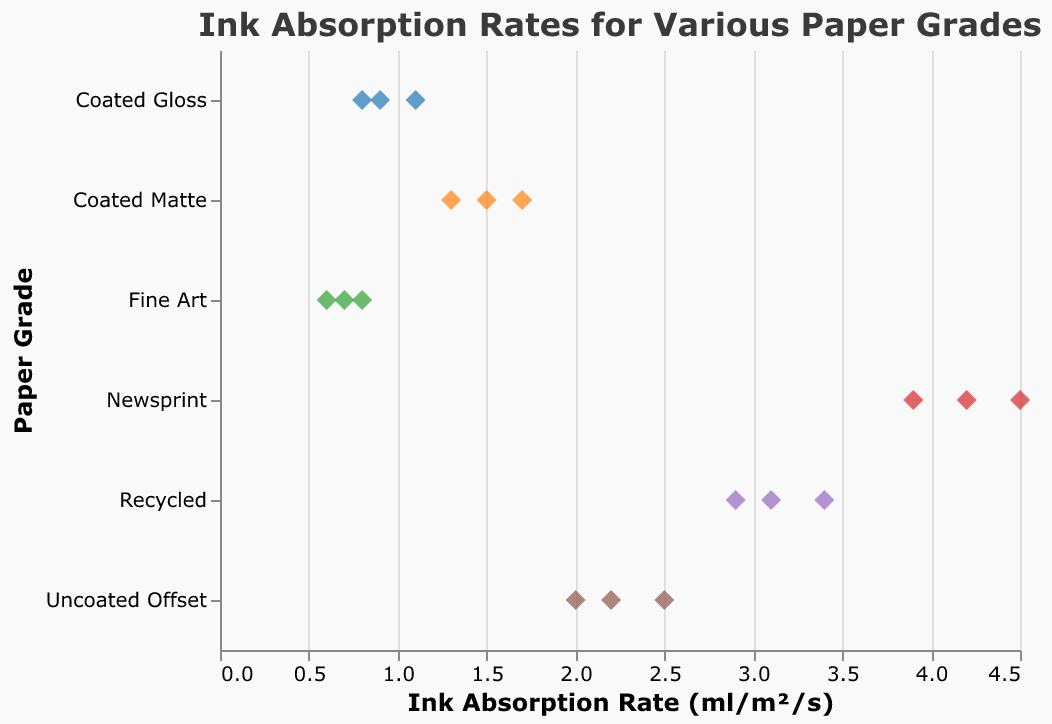What is the title of the figure? The title of the figure is displayed at the top of the plot. It summarizes the content of the plot.
Answer: Ink Absorption Rates for Various Paper Grades What are the paper grades shown on the y-axis? The y-axis displays different categories, in this case, various paper grades used in commercial printing.
Answer: Coated Gloss, Coated Matte, Uncoated Offset, Recycled, Newsprint, Fine Art Which paper grade has the highest ink absorption rate? To find the highest ink absorption rate, look for the maximum value in the horizontal direction for each paper grade. Newsprint has the highest value at 4.5 ml/m²/s.
Answer: Newsprint What is the range of ink absorption rates for Coated Matte paper? To find the range, identify the minimum and maximum values for Coated Matte paper on the x-axis. The values range from 1.3 to 1.7 ml/m²/s.
Answer: 1.3 to 1.7 ml/m²/s How does the ink absorption rate for Fine Art paper compare to Recycled paper? Compare the ink absorption rates by observing the positional range of dots on the x-axis for both Fine Art and Recycled paper grades. Fine Art paper (0.6 to 0.8 ml/m²/s) has a lower ink absorption rate range compared to Recycled paper (2.9 to 3.4 ml/m²/s).
Answer: Fine Art paper has a lower ink absorption rate Calculate the average ink absorption rate for Uncoated Offset paper. To calculate the average ink absorption rate, sum the values for Uncoated Offset paper (2.2 + 2.5 + 2.0 = 6.7) and divide by the number of data points (3).
Answer: 2.23 ml/m²/s Which paper grade has the lowest ink absorption rate? To find the lowest ink absorption rate, look for the minimum value in the horizontal direction across all paper grades. Fine Art has the lowest value at 0.6 ml/m²/s.
Answer: Fine Art Is there any overlap in ink absorption rates between Coated Gloss and Coated Matte paper? Look at the range of ink absorption rates for both Coated Gloss (0.8 to 1.1 ml/m²/s) and Coated Matte (1.3 to 1.7 ml/m²/s). There is no overlap.
Answer: No How many data points are there for Newsprint paper? Count the number of distinct points plotted for Newsprint paper on the strip plot.
Answer: 3 Which paper grades have overlapping ranges for their ink absorption rates? Compare the ranges of ink absorption rates for each paper grade: Coated Gloss (0.8-1.1) and Fine Art (0.6-0.8) overlap slightly; Uncoated Offset (2.0-2.5) and Recycled (2.9-3.4) do not overlap.
Answer: Coated Gloss and Fine Art What is the median ink absorption rate for Recycled paper? To find the median value, list the absorption rates for Recycled paper in numerical order (2.9, 3.1, 3.4) and identify the middle value.
Answer: 3.1 ml/m²/s 